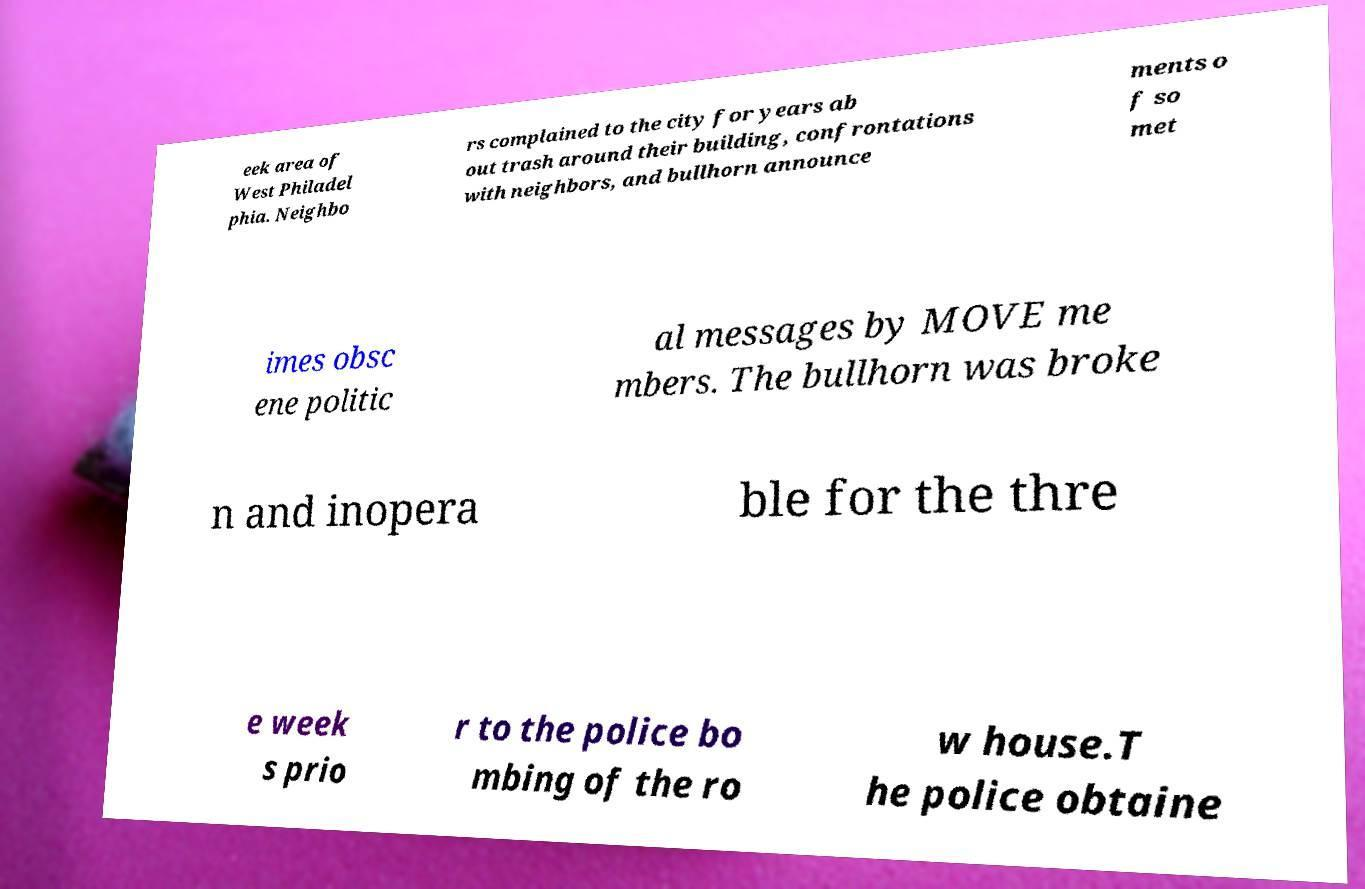Can you accurately transcribe the text from the provided image for me? eek area of West Philadel phia. Neighbo rs complained to the city for years ab out trash around their building, confrontations with neighbors, and bullhorn announce ments o f so met imes obsc ene politic al messages by MOVE me mbers. The bullhorn was broke n and inopera ble for the thre e week s prio r to the police bo mbing of the ro w house.T he police obtaine 